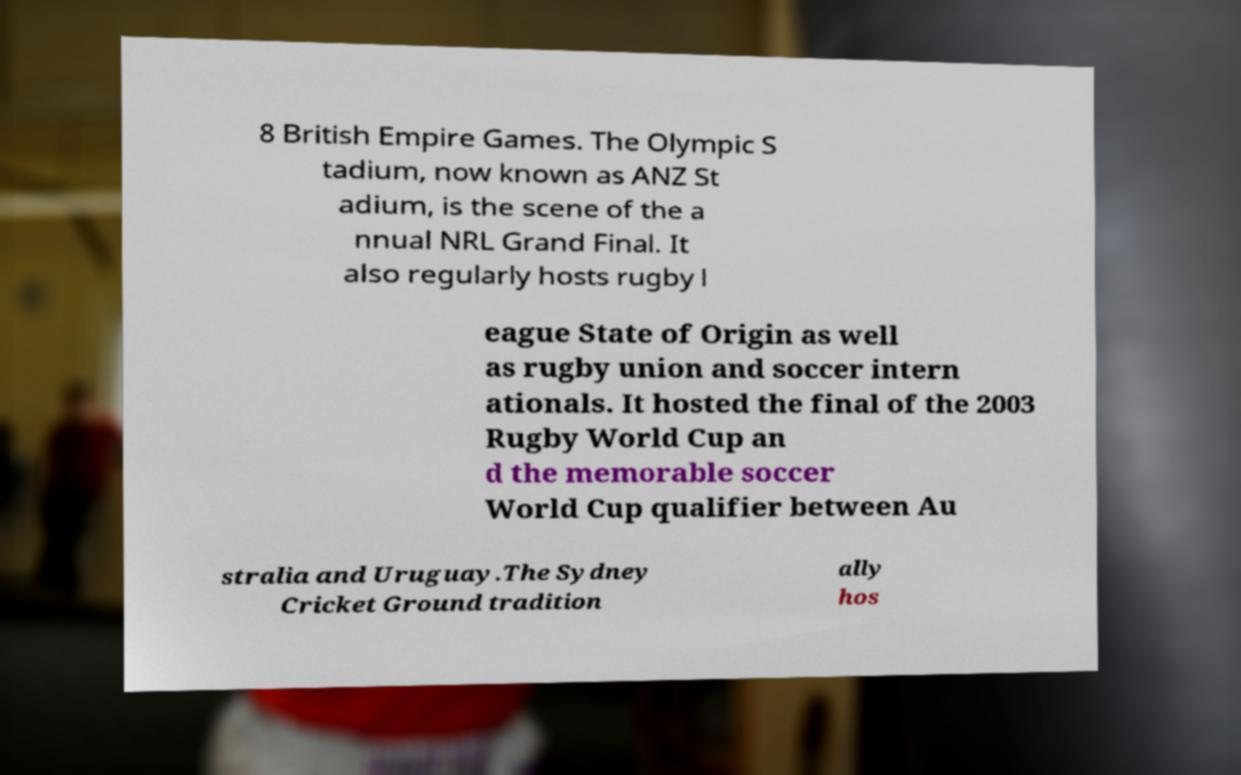Please read and relay the text visible in this image. What does it say? 8 British Empire Games. The Olympic S tadium, now known as ANZ St adium, is the scene of the a nnual NRL Grand Final. It also regularly hosts rugby l eague State of Origin as well as rugby union and soccer intern ationals. It hosted the final of the 2003 Rugby World Cup an d the memorable soccer World Cup qualifier between Au stralia and Uruguay.The Sydney Cricket Ground tradition ally hos 